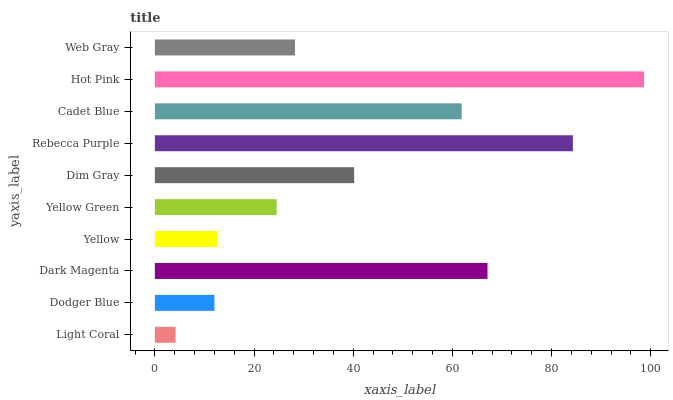Is Light Coral the minimum?
Answer yes or no. Yes. Is Hot Pink the maximum?
Answer yes or no. Yes. Is Dodger Blue the minimum?
Answer yes or no. No. Is Dodger Blue the maximum?
Answer yes or no. No. Is Dodger Blue greater than Light Coral?
Answer yes or no. Yes. Is Light Coral less than Dodger Blue?
Answer yes or no. Yes. Is Light Coral greater than Dodger Blue?
Answer yes or no. No. Is Dodger Blue less than Light Coral?
Answer yes or no. No. Is Dim Gray the high median?
Answer yes or no. Yes. Is Web Gray the low median?
Answer yes or no. Yes. Is Cadet Blue the high median?
Answer yes or no. No. Is Light Coral the low median?
Answer yes or no. No. 